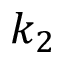<formula> <loc_0><loc_0><loc_500><loc_500>k _ { 2 }</formula> 